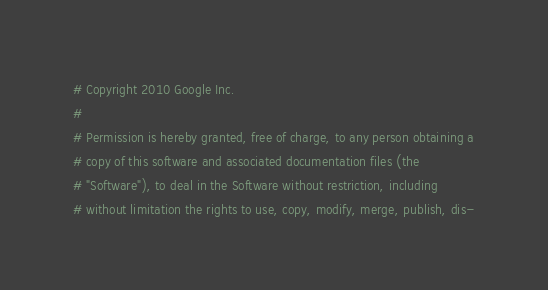<code> <loc_0><loc_0><loc_500><loc_500><_Python_># Copyright 2010 Google Inc.
#
# Permission is hereby granted, free of charge, to any person obtaining a
# copy of this software and associated documentation files (the
# "Software"), to deal in the Software without restriction, including
# without limitation the rights to use, copy, modify, merge, publish, dis-</code> 